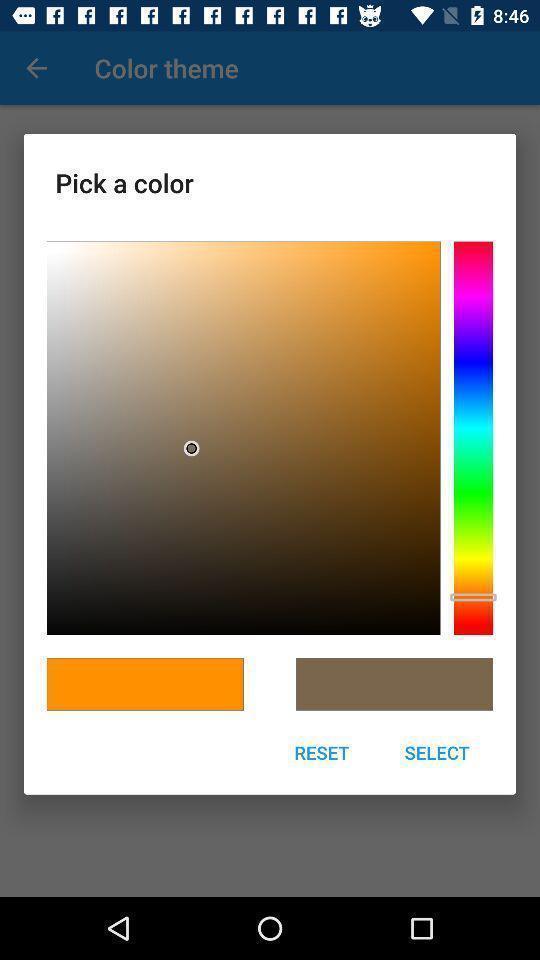Summarize the information in this screenshot. Pop-up shows pick color option. 